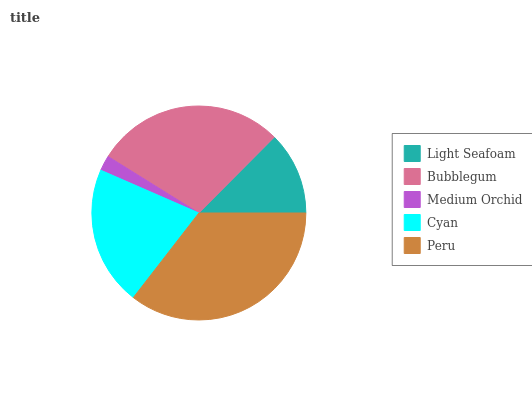Is Medium Orchid the minimum?
Answer yes or no. Yes. Is Peru the maximum?
Answer yes or no. Yes. Is Bubblegum the minimum?
Answer yes or no. No. Is Bubblegum the maximum?
Answer yes or no. No. Is Bubblegum greater than Light Seafoam?
Answer yes or no. Yes. Is Light Seafoam less than Bubblegum?
Answer yes or no. Yes. Is Light Seafoam greater than Bubblegum?
Answer yes or no. No. Is Bubblegum less than Light Seafoam?
Answer yes or no. No. Is Cyan the high median?
Answer yes or no. Yes. Is Cyan the low median?
Answer yes or no. Yes. Is Medium Orchid the high median?
Answer yes or no. No. Is Medium Orchid the low median?
Answer yes or no. No. 